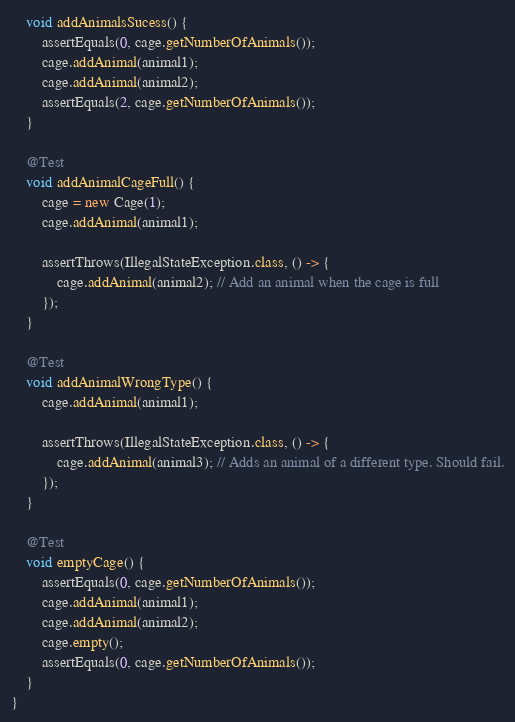Convert code to text. <code><loc_0><loc_0><loc_500><loc_500><_Java_>    void addAnimalsSucess() {
        assertEquals(0, cage.getNumberOfAnimals());
        cage.addAnimal(animal1);
        cage.addAnimal(animal2);
        assertEquals(2, cage.getNumberOfAnimals());
    }

    @Test
    void addAnimalCageFull() {
        cage = new Cage(1);
        cage.addAnimal(animal1);

        assertThrows(IllegalStateException.class, () -> {
            cage.addAnimal(animal2); // Add an animal when the cage is full
        });
    }

    @Test
    void addAnimalWrongType() {
        cage.addAnimal(animal1);

        assertThrows(IllegalStateException.class, () -> {
            cage.addAnimal(animal3); // Adds an animal of a different type. Should fail.
        });
    }

    @Test
    void emptyCage() {
        assertEquals(0, cage.getNumberOfAnimals());
        cage.addAnimal(animal1);
        cage.addAnimal(animal2);
        cage.empty();
        assertEquals(0, cage.getNumberOfAnimals());
    }
}
</code> 